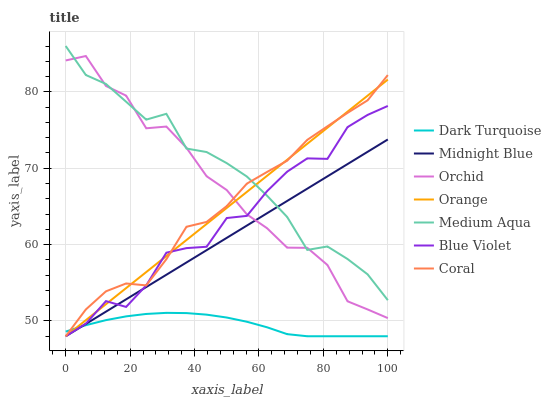Does Dark Turquoise have the minimum area under the curve?
Answer yes or no. Yes. Does Medium Aqua have the maximum area under the curve?
Answer yes or no. Yes. Does Coral have the minimum area under the curve?
Answer yes or no. No. Does Coral have the maximum area under the curve?
Answer yes or no. No. Is Orange the smoothest?
Answer yes or no. Yes. Is Orchid the roughest?
Answer yes or no. Yes. Is Dark Turquoise the smoothest?
Answer yes or no. No. Is Dark Turquoise the roughest?
Answer yes or no. No. Does Midnight Blue have the lowest value?
Answer yes or no. Yes. Does Medium Aqua have the lowest value?
Answer yes or no. No. Does Medium Aqua have the highest value?
Answer yes or no. Yes. Does Coral have the highest value?
Answer yes or no. No. Is Dark Turquoise less than Orchid?
Answer yes or no. Yes. Is Orchid greater than Dark Turquoise?
Answer yes or no. Yes. Does Midnight Blue intersect Medium Aqua?
Answer yes or no. Yes. Is Midnight Blue less than Medium Aqua?
Answer yes or no. No. Is Midnight Blue greater than Medium Aqua?
Answer yes or no. No. Does Dark Turquoise intersect Orchid?
Answer yes or no. No. 